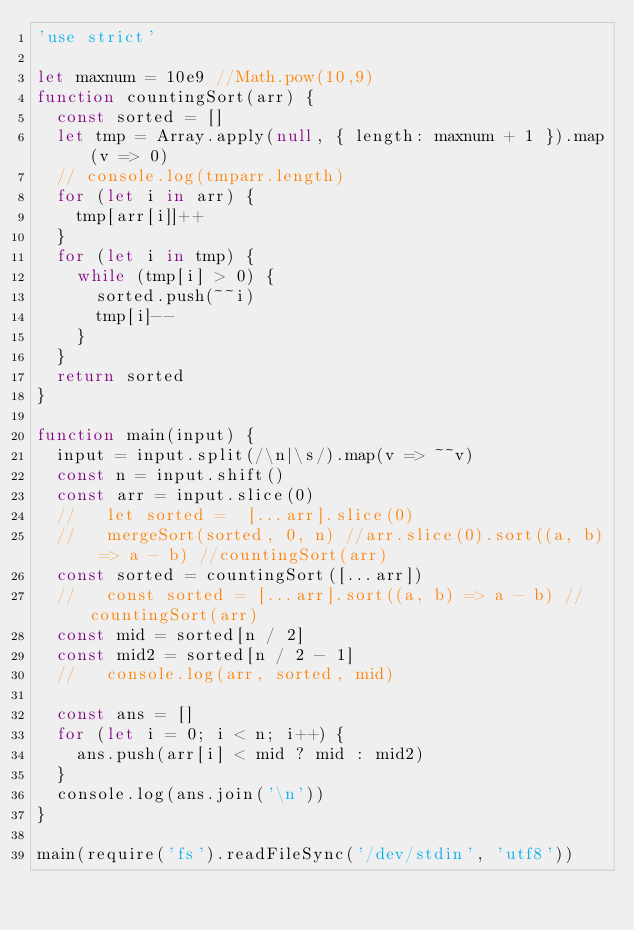<code> <loc_0><loc_0><loc_500><loc_500><_JavaScript_>'use strict'

let maxnum = 10e9 //Math.pow(10,9)
function countingSort(arr) {
  const sorted = []
  let tmp = Array.apply(null, { length: maxnum + 1 }).map(v => 0)
  // console.log(tmparr.length)
  for (let i in arr) {
    tmp[arr[i]]++
  }
  for (let i in tmp) {
    while (tmp[i] > 0) {
      sorted.push(~~i)
      tmp[i]--
    }
  }
  return sorted
}

function main(input) {
  input = input.split(/\n|\s/).map(v => ~~v)
  const n = input.shift()
  const arr = input.slice(0)
  //   let sorted =  [...arr].slice(0)
  //   mergeSort(sorted, 0, n) //arr.slice(0).sort((a, b) => a - b) //countingSort(arr)
  const sorted = countingSort([...arr])
  //   const sorted = [...arr].sort((a, b) => a - b) //countingSort(arr)
  const mid = sorted[n / 2]
  const mid2 = sorted[n / 2 - 1]
  //   console.log(arr, sorted, mid)

  const ans = []
  for (let i = 0; i < n; i++) {
    ans.push(arr[i] < mid ? mid : mid2)
  }
  console.log(ans.join('\n'))
}

main(require('fs').readFileSync('/dev/stdin', 'utf8'))
</code> 